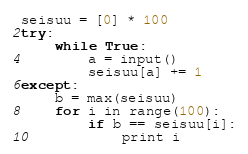<code> <loc_0><loc_0><loc_500><loc_500><_Python_>seisuu = [0] * 100
try:
    while True:
        a = input()
        seisuu[a] += 1
except:
    b = max(seisuu)
    for i in range(100):
        if b == seisuu[i]:
            print i</code> 